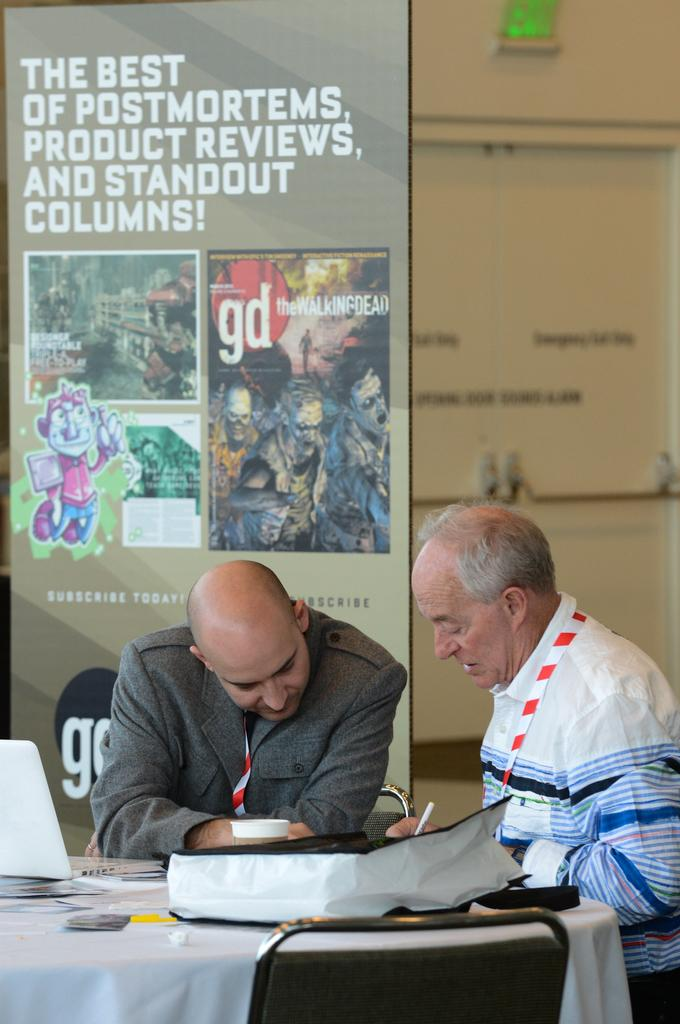Provide a one-sentence caption for the provided image. Two people having a meeting in front of a wall that says "The best of Postmortems, product reviews, and standout columns!". 